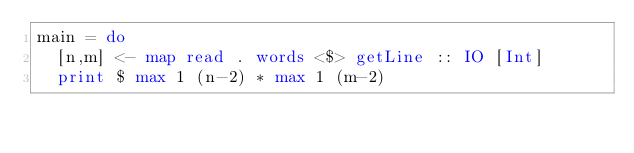Convert code to text. <code><loc_0><loc_0><loc_500><loc_500><_Haskell_>main = do
  [n,m] <- map read . words <$> getLine :: IO [Int]
  print $ max 1 (n-2) * max 1 (m-2)</code> 